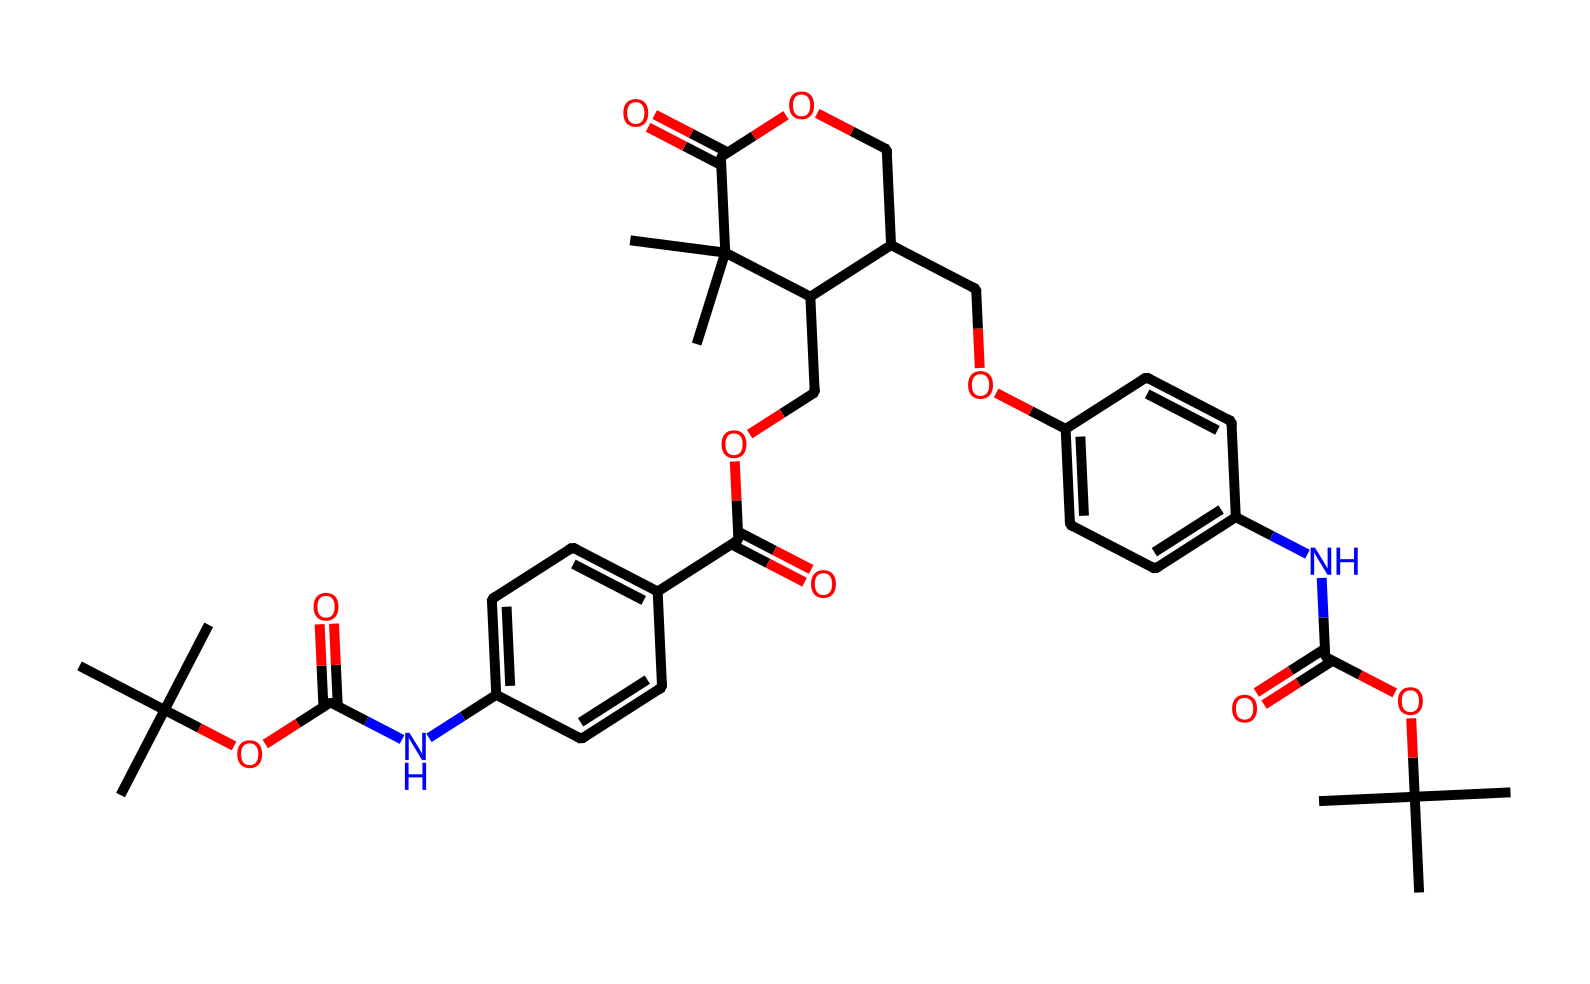What is the primary functional group in this chemical? The SMILES representation indicates the presence of an amide group (NC(=O)) and several ester groups (OC(=O)). The most prominent, central functional group is the amide.
Answer: amide How many carbon atoms are in this chemical? By analyzing the given SMILES, we can count all the carbon (C) atoms represented. There are 23 carbon atoms in total, including those in the side chains and rings.
Answer: 23 What type of bond connects the carbon and nitrogen atoms in the amide group? The connection between the carbon (C) and nitrogen (N) in the amide group is a single covalent bond, as indicated by the lack of any double bond notations in that part of the SMILES.
Answer: single bond What role do the ester groups play in biodegradable photoresists? The ester groups enhance the chemical stability and can aid in the degradation process, making them suitable for eco-friendly applications by facilitating hydrolysis in the presence of water.
Answer: enhance degradation How many rings are present in the chemical structure? Examining the structure reveals two aromatic rings (specifically benzene rings) in the chemical. The presence of the cyclic arrangements is confirmed through the connections between carbon atoms indicated in the SMILES.
Answer: 2 What is the significance of the cyclohexyl structure in the chemical? The cyclohexyl structure contributes to the rigidity and stability of the polymer backbone, which is crucial for defining the resist properties in photolithography applications.
Answer: stability 